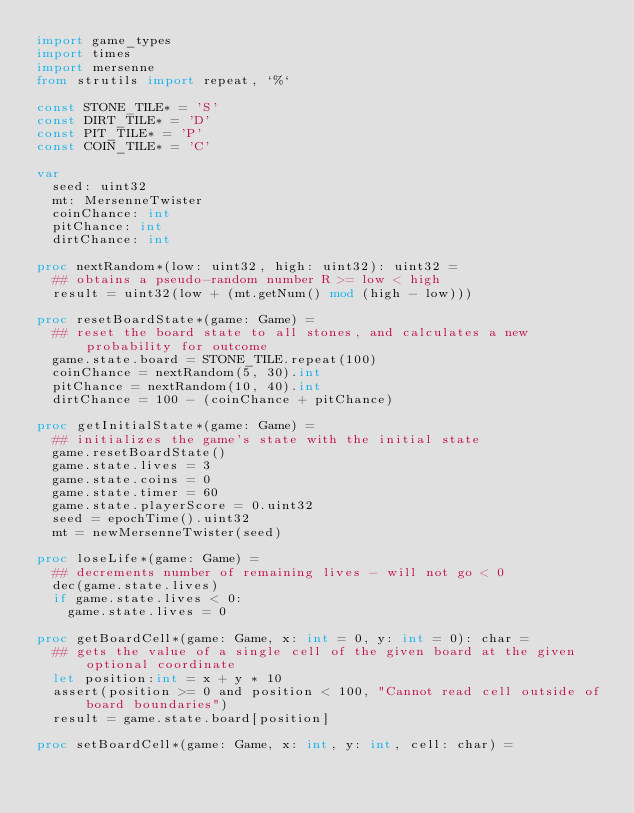<code> <loc_0><loc_0><loc_500><loc_500><_Nim_>import game_types
import times
import mersenne
from strutils import repeat, `%`

const STONE_TILE* = 'S'
const DIRT_TILE* = 'D'
const PIT_TILE* = 'P'
const COIN_TILE* = 'C'

var
  seed: uint32
  mt: MersenneTwister
  coinChance: int
  pitChance: int
  dirtChance: int

proc nextRandom*(low: uint32, high: uint32): uint32 =
  ## obtains a pseudo-random number R >= low < high
  result = uint32(low + (mt.getNum() mod (high - low)))

proc resetBoardState*(game: Game) =
  ## reset the board state to all stones, and calculates a new probability for outcome
  game.state.board = STONE_TILE.repeat(100)
  coinChance = nextRandom(5, 30).int
  pitChance = nextRandom(10, 40).int
  dirtChance = 100 - (coinChance + pitChance)

proc getInitialState*(game: Game) =
  ## initializes the game's state with the initial state
  game.resetBoardState()
  game.state.lives = 3
  game.state.coins = 0
  game.state.timer = 60
  game.state.playerScore = 0.uint32
  seed = epochTime().uint32
  mt = newMersenneTwister(seed)

proc loseLife*(game: Game) =
  ## decrements number of remaining lives - will not go < 0
  dec(game.state.lives)
  if game.state.lives < 0:
    game.state.lives = 0

proc getBoardCell*(game: Game, x: int = 0, y: int = 0): char =
  ## gets the value of a single cell of the given board at the given optional coordinate
  let position:int = x + y * 10
  assert(position >= 0 and position < 100, "Cannot read cell outside of board boundaries")
  result = game.state.board[position]

proc setBoardCell*(game: Game, x: int, y: int, cell: char) =</code> 